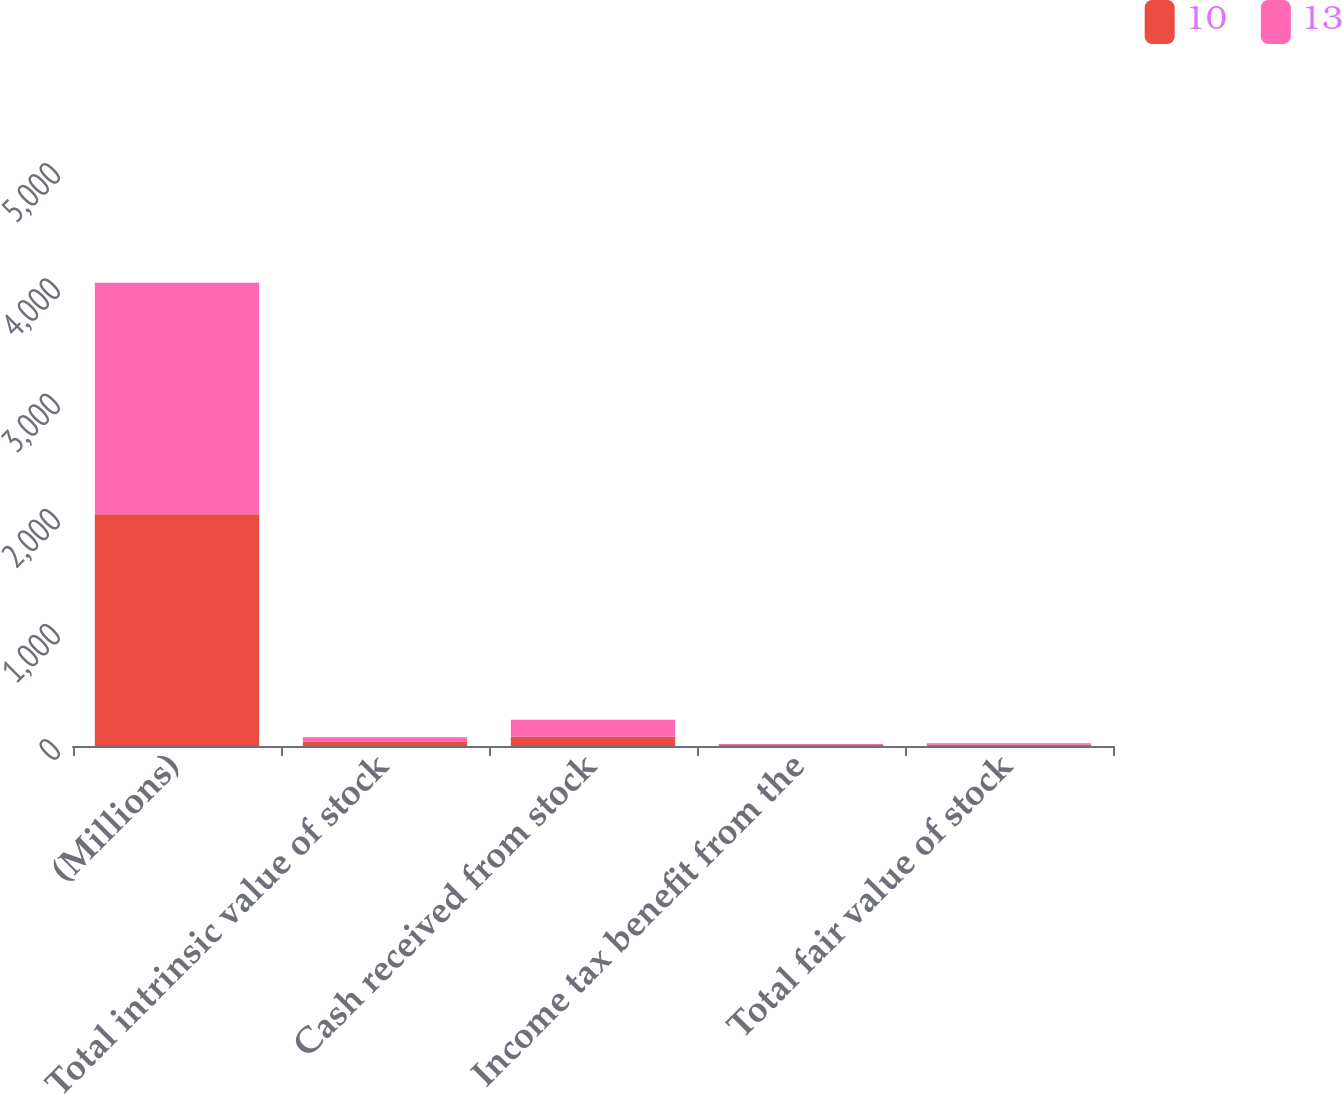Convert chart to OTSL. <chart><loc_0><loc_0><loc_500><loc_500><stacked_bar_chart><ecel><fcel>(Millions)<fcel>Total intrinsic value of stock<fcel>Cash received from stock<fcel>Income tax benefit from the<fcel>Total fair value of stock<nl><fcel>10<fcel>2011<fcel>40<fcel>81<fcel>9<fcel>10<nl><fcel>13<fcel>2010<fcel>37<fcel>146<fcel>9<fcel>13<nl></chart> 